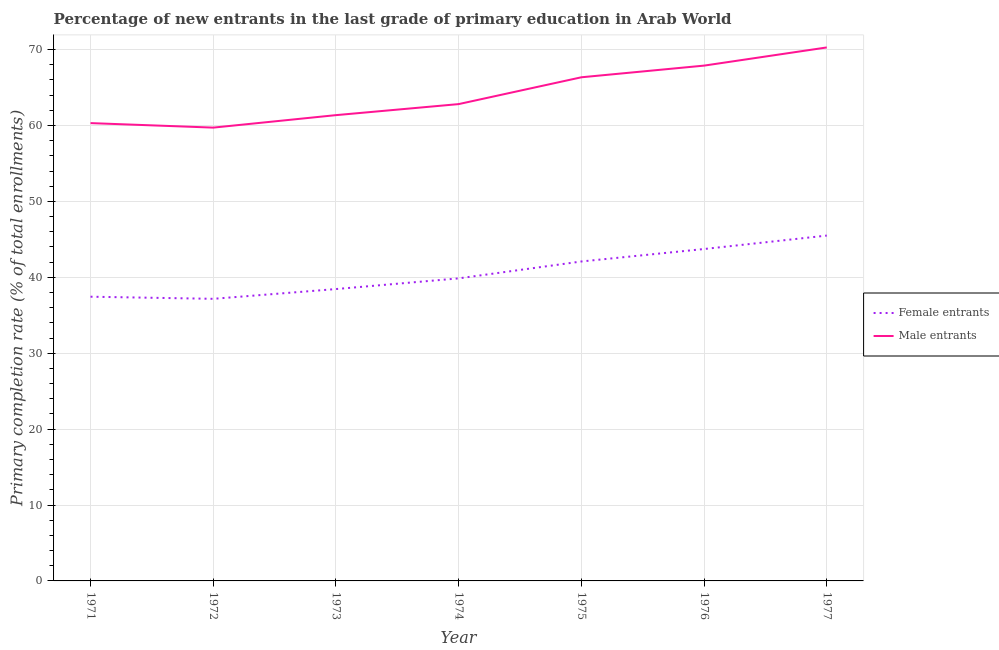How many different coloured lines are there?
Keep it short and to the point. 2. What is the primary completion rate of male entrants in 1973?
Offer a terse response. 61.36. Across all years, what is the maximum primary completion rate of female entrants?
Give a very brief answer. 45.5. Across all years, what is the minimum primary completion rate of male entrants?
Make the answer very short. 59.72. In which year was the primary completion rate of male entrants maximum?
Keep it short and to the point. 1977. In which year was the primary completion rate of male entrants minimum?
Ensure brevity in your answer.  1972. What is the total primary completion rate of female entrants in the graph?
Your response must be concise. 284.22. What is the difference between the primary completion rate of female entrants in 1974 and that in 1975?
Offer a very short reply. -2.23. What is the difference between the primary completion rate of male entrants in 1977 and the primary completion rate of female entrants in 1971?
Keep it short and to the point. 32.84. What is the average primary completion rate of male entrants per year?
Offer a very short reply. 64.1. In the year 1974, what is the difference between the primary completion rate of female entrants and primary completion rate of male entrants?
Your answer should be very brief. -22.96. What is the ratio of the primary completion rate of male entrants in 1971 to that in 1975?
Ensure brevity in your answer.  0.91. Is the primary completion rate of female entrants in 1972 less than that in 1977?
Give a very brief answer. Yes. What is the difference between the highest and the second highest primary completion rate of female entrants?
Give a very brief answer. 1.77. What is the difference between the highest and the lowest primary completion rate of male entrants?
Offer a very short reply. 10.56. In how many years, is the primary completion rate of female entrants greater than the average primary completion rate of female entrants taken over all years?
Your answer should be very brief. 3. Is the sum of the primary completion rate of male entrants in 1971 and 1976 greater than the maximum primary completion rate of female entrants across all years?
Ensure brevity in your answer.  Yes. Is the primary completion rate of female entrants strictly greater than the primary completion rate of male entrants over the years?
Keep it short and to the point. No. How many lines are there?
Keep it short and to the point. 2. How many years are there in the graph?
Your answer should be compact. 7. Where does the legend appear in the graph?
Ensure brevity in your answer.  Center right. How many legend labels are there?
Make the answer very short. 2. What is the title of the graph?
Give a very brief answer. Percentage of new entrants in the last grade of primary education in Arab World. What is the label or title of the X-axis?
Offer a terse response. Year. What is the label or title of the Y-axis?
Your response must be concise. Primary completion rate (% of total enrollments). What is the Primary completion rate (% of total enrollments) in Female entrants in 1971?
Offer a terse response. 37.44. What is the Primary completion rate (% of total enrollments) in Male entrants in 1971?
Your answer should be compact. 60.31. What is the Primary completion rate (% of total enrollments) in Female entrants in 1972?
Your response must be concise. 37.16. What is the Primary completion rate (% of total enrollments) in Male entrants in 1972?
Offer a terse response. 59.72. What is the Primary completion rate (% of total enrollments) in Female entrants in 1973?
Ensure brevity in your answer.  38.45. What is the Primary completion rate (% of total enrollments) of Male entrants in 1973?
Make the answer very short. 61.36. What is the Primary completion rate (% of total enrollments) of Female entrants in 1974?
Provide a short and direct response. 39.86. What is the Primary completion rate (% of total enrollments) in Male entrants in 1974?
Provide a succinct answer. 62.82. What is the Primary completion rate (% of total enrollments) in Female entrants in 1975?
Make the answer very short. 42.08. What is the Primary completion rate (% of total enrollments) in Male entrants in 1975?
Give a very brief answer. 66.35. What is the Primary completion rate (% of total enrollments) in Female entrants in 1976?
Offer a very short reply. 43.73. What is the Primary completion rate (% of total enrollments) in Male entrants in 1976?
Your response must be concise. 67.89. What is the Primary completion rate (% of total enrollments) in Female entrants in 1977?
Your answer should be compact. 45.5. What is the Primary completion rate (% of total enrollments) of Male entrants in 1977?
Keep it short and to the point. 70.28. Across all years, what is the maximum Primary completion rate (% of total enrollments) in Female entrants?
Offer a very short reply. 45.5. Across all years, what is the maximum Primary completion rate (% of total enrollments) of Male entrants?
Keep it short and to the point. 70.28. Across all years, what is the minimum Primary completion rate (% of total enrollments) of Female entrants?
Your answer should be compact. 37.16. Across all years, what is the minimum Primary completion rate (% of total enrollments) in Male entrants?
Offer a very short reply. 59.72. What is the total Primary completion rate (% of total enrollments) in Female entrants in the graph?
Ensure brevity in your answer.  284.22. What is the total Primary completion rate (% of total enrollments) of Male entrants in the graph?
Your response must be concise. 448.73. What is the difference between the Primary completion rate (% of total enrollments) in Female entrants in 1971 and that in 1972?
Offer a very short reply. 0.28. What is the difference between the Primary completion rate (% of total enrollments) in Male entrants in 1971 and that in 1972?
Keep it short and to the point. 0.59. What is the difference between the Primary completion rate (% of total enrollments) of Female entrants in 1971 and that in 1973?
Make the answer very short. -1.01. What is the difference between the Primary completion rate (% of total enrollments) of Male entrants in 1971 and that in 1973?
Keep it short and to the point. -1.05. What is the difference between the Primary completion rate (% of total enrollments) in Female entrants in 1971 and that in 1974?
Ensure brevity in your answer.  -2.42. What is the difference between the Primary completion rate (% of total enrollments) of Male entrants in 1971 and that in 1974?
Keep it short and to the point. -2.5. What is the difference between the Primary completion rate (% of total enrollments) of Female entrants in 1971 and that in 1975?
Offer a very short reply. -4.64. What is the difference between the Primary completion rate (% of total enrollments) in Male entrants in 1971 and that in 1975?
Give a very brief answer. -6.04. What is the difference between the Primary completion rate (% of total enrollments) in Female entrants in 1971 and that in 1976?
Make the answer very short. -6.28. What is the difference between the Primary completion rate (% of total enrollments) of Male entrants in 1971 and that in 1976?
Offer a very short reply. -7.57. What is the difference between the Primary completion rate (% of total enrollments) in Female entrants in 1971 and that in 1977?
Offer a terse response. -8.05. What is the difference between the Primary completion rate (% of total enrollments) in Male entrants in 1971 and that in 1977?
Ensure brevity in your answer.  -9.97. What is the difference between the Primary completion rate (% of total enrollments) of Female entrants in 1972 and that in 1973?
Offer a very short reply. -1.29. What is the difference between the Primary completion rate (% of total enrollments) in Male entrants in 1972 and that in 1973?
Ensure brevity in your answer.  -1.64. What is the difference between the Primary completion rate (% of total enrollments) in Female entrants in 1972 and that in 1974?
Make the answer very short. -2.69. What is the difference between the Primary completion rate (% of total enrollments) in Male entrants in 1972 and that in 1974?
Your response must be concise. -3.1. What is the difference between the Primary completion rate (% of total enrollments) in Female entrants in 1972 and that in 1975?
Offer a terse response. -4.92. What is the difference between the Primary completion rate (% of total enrollments) of Male entrants in 1972 and that in 1975?
Ensure brevity in your answer.  -6.63. What is the difference between the Primary completion rate (% of total enrollments) of Female entrants in 1972 and that in 1976?
Offer a very short reply. -6.56. What is the difference between the Primary completion rate (% of total enrollments) in Male entrants in 1972 and that in 1976?
Keep it short and to the point. -8.17. What is the difference between the Primary completion rate (% of total enrollments) in Female entrants in 1972 and that in 1977?
Give a very brief answer. -8.33. What is the difference between the Primary completion rate (% of total enrollments) in Male entrants in 1972 and that in 1977?
Your answer should be compact. -10.56. What is the difference between the Primary completion rate (% of total enrollments) in Female entrants in 1973 and that in 1974?
Offer a very short reply. -1.41. What is the difference between the Primary completion rate (% of total enrollments) in Male entrants in 1973 and that in 1974?
Keep it short and to the point. -1.45. What is the difference between the Primary completion rate (% of total enrollments) in Female entrants in 1973 and that in 1975?
Give a very brief answer. -3.63. What is the difference between the Primary completion rate (% of total enrollments) of Male entrants in 1973 and that in 1975?
Make the answer very short. -4.99. What is the difference between the Primary completion rate (% of total enrollments) of Female entrants in 1973 and that in 1976?
Give a very brief answer. -5.28. What is the difference between the Primary completion rate (% of total enrollments) of Male entrants in 1973 and that in 1976?
Your answer should be compact. -6.52. What is the difference between the Primary completion rate (% of total enrollments) in Female entrants in 1973 and that in 1977?
Your response must be concise. -7.05. What is the difference between the Primary completion rate (% of total enrollments) in Male entrants in 1973 and that in 1977?
Your answer should be compact. -8.92. What is the difference between the Primary completion rate (% of total enrollments) of Female entrants in 1974 and that in 1975?
Your answer should be compact. -2.23. What is the difference between the Primary completion rate (% of total enrollments) of Male entrants in 1974 and that in 1975?
Provide a short and direct response. -3.53. What is the difference between the Primary completion rate (% of total enrollments) of Female entrants in 1974 and that in 1976?
Offer a terse response. -3.87. What is the difference between the Primary completion rate (% of total enrollments) in Male entrants in 1974 and that in 1976?
Your answer should be compact. -5.07. What is the difference between the Primary completion rate (% of total enrollments) of Female entrants in 1974 and that in 1977?
Your answer should be very brief. -5.64. What is the difference between the Primary completion rate (% of total enrollments) in Male entrants in 1974 and that in 1977?
Provide a short and direct response. -7.46. What is the difference between the Primary completion rate (% of total enrollments) of Female entrants in 1975 and that in 1976?
Offer a terse response. -1.64. What is the difference between the Primary completion rate (% of total enrollments) of Male entrants in 1975 and that in 1976?
Your response must be concise. -1.54. What is the difference between the Primary completion rate (% of total enrollments) in Female entrants in 1975 and that in 1977?
Make the answer very short. -3.41. What is the difference between the Primary completion rate (% of total enrollments) of Male entrants in 1975 and that in 1977?
Provide a short and direct response. -3.93. What is the difference between the Primary completion rate (% of total enrollments) of Female entrants in 1976 and that in 1977?
Offer a very short reply. -1.77. What is the difference between the Primary completion rate (% of total enrollments) in Male entrants in 1976 and that in 1977?
Your response must be concise. -2.39. What is the difference between the Primary completion rate (% of total enrollments) in Female entrants in 1971 and the Primary completion rate (% of total enrollments) in Male entrants in 1972?
Your answer should be compact. -22.28. What is the difference between the Primary completion rate (% of total enrollments) of Female entrants in 1971 and the Primary completion rate (% of total enrollments) of Male entrants in 1973?
Provide a short and direct response. -23.92. What is the difference between the Primary completion rate (% of total enrollments) of Female entrants in 1971 and the Primary completion rate (% of total enrollments) of Male entrants in 1974?
Offer a very short reply. -25.37. What is the difference between the Primary completion rate (% of total enrollments) in Female entrants in 1971 and the Primary completion rate (% of total enrollments) in Male entrants in 1975?
Ensure brevity in your answer.  -28.91. What is the difference between the Primary completion rate (% of total enrollments) in Female entrants in 1971 and the Primary completion rate (% of total enrollments) in Male entrants in 1976?
Provide a succinct answer. -30.44. What is the difference between the Primary completion rate (% of total enrollments) of Female entrants in 1971 and the Primary completion rate (% of total enrollments) of Male entrants in 1977?
Offer a terse response. -32.84. What is the difference between the Primary completion rate (% of total enrollments) of Female entrants in 1972 and the Primary completion rate (% of total enrollments) of Male entrants in 1973?
Your response must be concise. -24.2. What is the difference between the Primary completion rate (% of total enrollments) of Female entrants in 1972 and the Primary completion rate (% of total enrollments) of Male entrants in 1974?
Offer a very short reply. -25.65. What is the difference between the Primary completion rate (% of total enrollments) of Female entrants in 1972 and the Primary completion rate (% of total enrollments) of Male entrants in 1975?
Provide a succinct answer. -29.19. What is the difference between the Primary completion rate (% of total enrollments) of Female entrants in 1972 and the Primary completion rate (% of total enrollments) of Male entrants in 1976?
Provide a short and direct response. -30.72. What is the difference between the Primary completion rate (% of total enrollments) in Female entrants in 1972 and the Primary completion rate (% of total enrollments) in Male entrants in 1977?
Your answer should be very brief. -33.12. What is the difference between the Primary completion rate (% of total enrollments) in Female entrants in 1973 and the Primary completion rate (% of total enrollments) in Male entrants in 1974?
Your response must be concise. -24.37. What is the difference between the Primary completion rate (% of total enrollments) in Female entrants in 1973 and the Primary completion rate (% of total enrollments) in Male entrants in 1975?
Your answer should be very brief. -27.9. What is the difference between the Primary completion rate (% of total enrollments) in Female entrants in 1973 and the Primary completion rate (% of total enrollments) in Male entrants in 1976?
Offer a terse response. -29.44. What is the difference between the Primary completion rate (% of total enrollments) in Female entrants in 1973 and the Primary completion rate (% of total enrollments) in Male entrants in 1977?
Ensure brevity in your answer.  -31.83. What is the difference between the Primary completion rate (% of total enrollments) in Female entrants in 1974 and the Primary completion rate (% of total enrollments) in Male entrants in 1975?
Your answer should be very brief. -26.49. What is the difference between the Primary completion rate (% of total enrollments) in Female entrants in 1974 and the Primary completion rate (% of total enrollments) in Male entrants in 1976?
Provide a succinct answer. -28.03. What is the difference between the Primary completion rate (% of total enrollments) of Female entrants in 1974 and the Primary completion rate (% of total enrollments) of Male entrants in 1977?
Keep it short and to the point. -30.42. What is the difference between the Primary completion rate (% of total enrollments) of Female entrants in 1975 and the Primary completion rate (% of total enrollments) of Male entrants in 1976?
Your answer should be compact. -25.8. What is the difference between the Primary completion rate (% of total enrollments) in Female entrants in 1975 and the Primary completion rate (% of total enrollments) in Male entrants in 1977?
Give a very brief answer. -28.2. What is the difference between the Primary completion rate (% of total enrollments) in Female entrants in 1976 and the Primary completion rate (% of total enrollments) in Male entrants in 1977?
Offer a terse response. -26.55. What is the average Primary completion rate (% of total enrollments) in Female entrants per year?
Keep it short and to the point. 40.6. What is the average Primary completion rate (% of total enrollments) of Male entrants per year?
Keep it short and to the point. 64.1. In the year 1971, what is the difference between the Primary completion rate (% of total enrollments) in Female entrants and Primary completion rate (% of total enrollments) in Male entrants?
Your answer should be very brief. -22.87. In the year 1972, what is the difference between the Primary completion rate (% of total enrollments) in Female entrants and Primary completion rate (% of total enrollments) in Male entrants?
Your answer should be compact. -22.56. In the year 1973, what is the difference between the Primary completion rate (% of total enrollments) in Female entrants and Primary completion rate (% of total enrollments) in Male entrants?
Offer a terse response. -22.91. In the year 1974, what is the difference between the Primary completion rate (% of total enrollments) of Female entrants and Primary completion rate (% of total enrollments) of Male entrants?
Your answer should be compact. -22.96. In the year 1975, what is the difference between the Primary completion rate (% of total enrollments) of Female entrants and Primary completion rate (% of total enrollments) of Male entrants?
Provide a short and direct response. -24.27. In the year 1976, what is the difference between the Primary completion rate (% of total enrollments) in Female entrants and Primary completion rate (% of total enrollments) in Male entrants?
Your answer should be compact. -24.16. In the year 1977, what is the difference between the Primary completion rate (% of total enrollments) in Female entrants and Primary completion rate (% of total enrollments) in Male entrants?
Your response must be concise. -24.78. What is the ratio of the Primary completion rate (% of total enrollments) in Female entrants in 1971 to that in 1972?
Ensure brevity in your answer.  1.01. What is the ratio of the Primary completion rate (% of total enrollments) of Male entrants in 1971 to that in 1972?
Give a very brief answer. 1.01. What is the ratio of the Primary completion rate (% of total enrollments) in Female entrants in 1971 to that in 1973?
Keep it short and to the point. 0.97. What is the ratio of the Primary completion rate (% of total enrollments) in Male entrants in 1971 to that in 1973?
Offer a very short reply. 0.98. What is the ratio of the Primary completion rate (% of total enrollments) in Female entrants in 1971 to that in 1974?
Provide a short and direct response. 0.94. What is the ratio of the Primary completion rate (% of total enrollments) of Male entrants in 1971 to that in 1974?
Offer a terse response. 0.96. What is the ratio of the Primary completion rate (% of total enrollments) of Female entrants in 1971 to that in 1975?
Give a very brief answer. 0.89. What is the ratio of the Primary completion rate (% of total enrollments) in Male entrants in 1971 to that in 1975?
Give a very brief answer. 0.91. What is the ratio of the Primary completion rate (% of total enrollments) of Female entrants in 1971 to that in 1976?
Give a very brief answer. 0.86. What is the ratio of the Primary completion rate (% of total enrollments) in Male entrants in 1971 to that in 1976?
Offer a very short reply. 0.89. What is the ratio of the Primary completion rate (% of total enrollments) of Female entrants in 1971 to that in 1977?
Make the answer very short. 0.82. What is the ratio of the Primary completion rate (% of total enrollments) of Male entrants in 1971 to that in 1977?
Provide a short and direct response. 0.86. What is the ratio of the Primary completion rate (% of total enrollments) of Female entrants in 1972 to that in 1973?
Provide a succinct answer. 0.97. What is the ratio of the Primary completion rate (% of total enrollments) in Male entrants in 1972 to that in 1973?
Provide a succinct answer. 0.97. What is the ratio of the Primary completion rate (% of total enrollments) of Female entrants in 1972 to that in 1974?
Provide a short and direct response. 0.93. What is the ratio of the Primary completion rate (% of total enrollments) of Male entrants in 1972 to that in 1974?
Offer a terse response. 0.95. What is the ratio of the Primary completion rate (% of total enrollments) of Female entrants in 1972 to that in 1975?
Provide a short and direct response. 0.88. What is the ratio of the Primary completion rate (% of total enrollments) in Male entrants in 1972 to that in 1975?
Keep it short and to the point. 0.9. What is the ratio of the Primary completion rate (% of total enrollments) in Female entrants in 1972 to that in 1976?
Keep it short and to the point. 0.85. What is the ratio of the Primary completion rate (% of total enrollments) in Male entrants in 1972 to that in 1976?
Your response must be concise. 0.88. What is the ratio of the Primary completion rate (% of total enrollments) of Female entrants in 1972 to that in 1977?
Provide a succinct answer. 0.82. What is the ratio of the Primary completion rate (% of total enrollments) in Male entrants in 1972 to that in 1977?
Your answer should be very brief. 0.85. What is the ratio of the Primary completion rate (% of total enrollments) of Female entrants in 1973 to that in 1974?
Your answer should be compact. 0.96. What is the ratio of the Primary completion rate (% of total enrollments) in Male entrants in 1973 to that in 1974?
Your response must be concise. 0.98. What is the ratio of the Primary completion rate (% of total enrollments) in Female entrants in 1973 to that in 1975?
Provide a succinct answer. 0.91. What is the ratio of the Primary completion rate (% of total enrollments) of Male entrants in 1973 to that in 1975?
Provide a short and direct response. 0.92. What is the ratio of the Primary completion rate (% of total enrollments) of Female entrants in 1973 to that in 1976?
Keep it short and to the point. 0.88. What is the ratio of the Primary completion rate (% of total enrollments) in Male entrants in 1973 to that in 1976?
Make the answer very short. 0.9. What is the ratio of the Primary completion rate (% of total enrollments) in Female entrants in 1973 to that in 1977?
Your answer should be very brief. 0.85. What is the ratio of the Primary completion rate (% of total enrollments) in Male entrants in 1973 to that in 1977?
Your answer should be very brief. 0.87. What is the ratio of the Primary completion rate (% of total enrollments) of Female entrants in 1974 to that in 1975?
Make the answer very short. 0.95. What is the ratio of the Primary completion rate (% of total enrollments) of Male entrants in 1974 to that in 1975?
Provide a succinct answer. 0.95. What is the ratio of the Primary completion rate (% of total enrollments) of Female entrants in 1974 to that in 1976?
Provide a short and direct response. 0.91. What is the ratio of the Primary completion rate (% of total enrollments) of Male entrants in 1974 to that in 1976?
Offer a terse response. 0.93. What is the ratio of the Primary completion rate (% of total enrollments) of Female entrants in 1974 to that in 1977?
Your response must be concise. 0.88. What is the ratio of the Primary completion rate (% of total enrollments) of Male entrants in 1974 to that in 1977?
Make the answer very short. 0.89. What is the ratio of the Primary completion rate (% of total enrollments) of Female entrants in 1975 to that in 1976?
Offer a very short reply. 0.96. What is the ratio of the Primary completion rate (% of total enrollments) of Male entrants in 1975 to that in 1976?
Make the answer very short. 0.98. What is the ratio of the Primary completion rate (% of total enrollments) in Female entrants in 1975 to that in 1977?
Ensure brevity in your answer.  0.93. What is the ratio of the Primary completion rate (% of total enrollments) in Male entrants in 1975 to that in 1977?
Offer a terse response. 0.94. What is the ratio of the Primary completion rate (% of total enrollments) of Female entrants in 1976 to that in 1977?
Your answer should be compact. 0.96. What is the ratio of the Primary completion rate (% of total enrollments) in Male entrants in 1976 to that in 1977?
Offer a very short reply. 0.97. What is the difference between the highest and the second highest Primary completion rate (% of total enrollments) in Female entrants?
Keep it short and to the point. 1.77. What is the difference between the highest and the second highest Primary completion rate (% of total enrollments) of Male entrants?
Your answer should be very brief. 2.39. What is the difference between the highest and the lowest Primary completion rate (% of total enrollments) in Female entrants?
Offer a very short reply. 8.33. What is the difference between the highest and the lowest Primary completion rate (% of total enrollments) of Male entrants?
Provide a short and direct response. 10.56. 